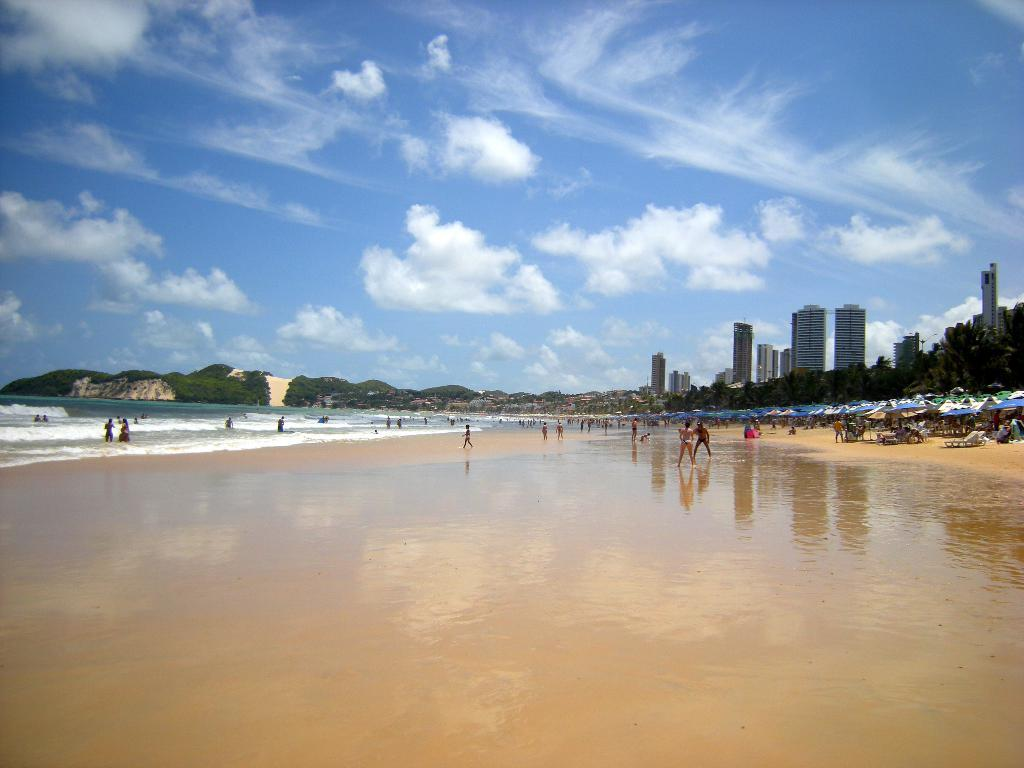What type of terrain is visible in the image? There is water, sand, and hills visible in the image. What structures are present in the image? There are buildings and umbrellas in the image. What type of vegetation can be seen in the image? There are trees in the image. How many people are present in the image? There is a group of people in the image. What is the opinion of the zinc on the division of the water and sand in the image? There is no zinc present in the image, and therefore no opinion can be attributed to it. 